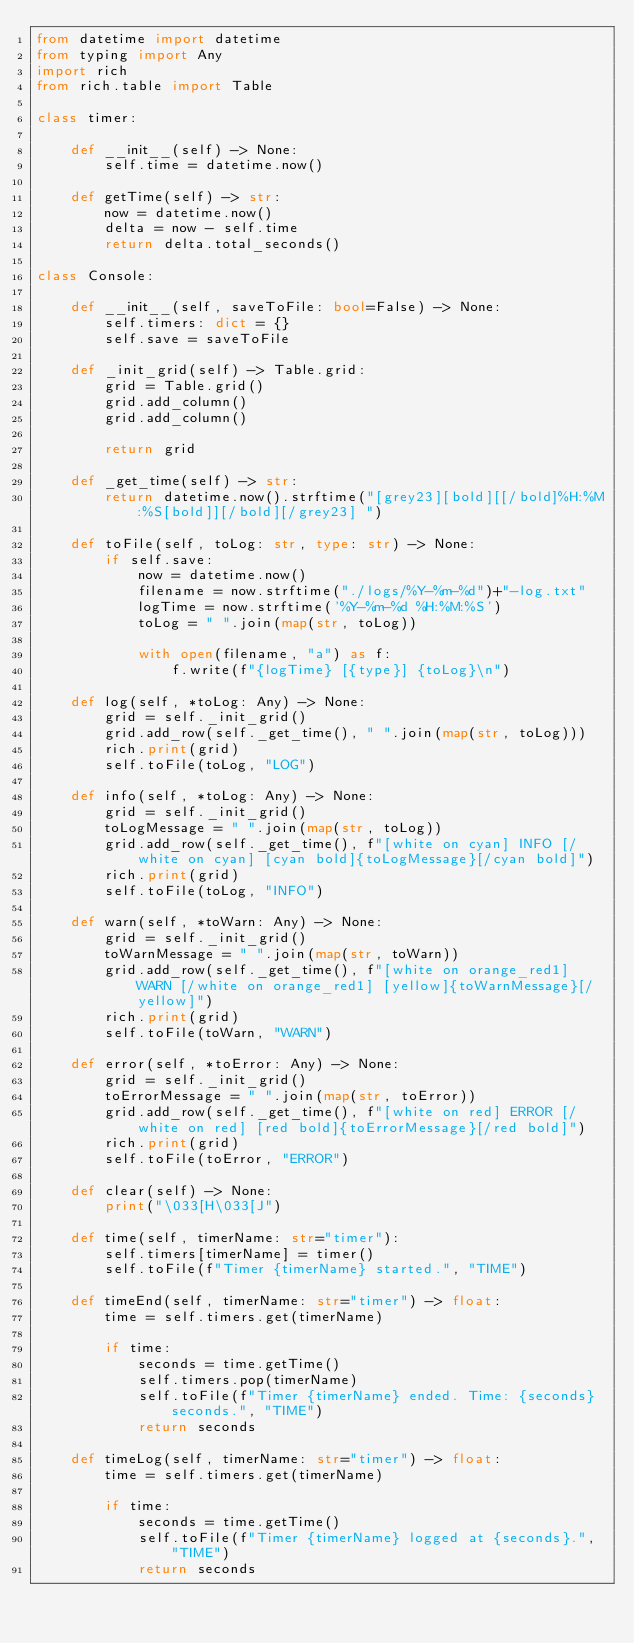Convert code to text. <code><loc_0><loc_0><loc_500><loc_500><_Python_>from datetime import datetime
from typing import Any
import rich
from rich.table import Table

class timer:

    def __init__(self) -> None:
        self.time = datetime.now()

    def getTime(self) -> str:
        now = datetime.now()
        delta = now - self.time
        return delta.total_seconds()

class Console:

    def __init__(self, saveToFile: bool=False) -> None:
        self.timers: dict = {}
        self.save = saveToFile

    def _init_grid(self) -> Table.grid:
        grid = Table.grid()
        grid.add_column()
        grid.add_column()

        return grid

    def _get_time(self) -> str:
        return datetime.now().strftime("[grey23][bold][[/bold]%H:%M:%S[bold]][/bold][/grey23] ")

    def toFile(self, toLog: str, type: str) -> None:
        if self.save:
            now = datetime.now()
            filename = now.strftime("./logs/%Y-%m-%d")+"-log.txt"
            logTime = now.strftime('%Y-%m-%d %H:%M:%S')
            toLog = " ".join(map(str, toLog))

            with open(filename, "a") as f:
                f.write(f"{logTime} [{type}] {toLog}\n")

    def log(self, *toLog: Any) -> None:
        grid = self._init_grid()
        grid.add_row(self._get_time(), " ".join(map(str, toLog)))
        rich.print(grid)
        self.toFile(toLog, "LOG")

    def info(self, *toLog: Any) -> None:
        grid = self._init_grid()
        toLogMessage = " ".join(map(str, toLog))
        grid.add_row(self._get_time(), f"[white on cyan] INFO [/white on cyan] [cyan bold]{toLogMessage}[/cyan bold]")
        rich.print(grid)
        self.toFile(toLog, "INFO")

    def warn(self, *toWarn: Any) -> None:
        grid = self._init_grid()
        toWarnMessage = " ".join(map(str, toWarn))
        grid.add_row(self._get_time(), f"[white on orange_red1] WARN [/white on orange_red1] [yellow]{toWarnMessage}[/yellow]")
        rich.print(grid)
        self.toFile(toWarn, "WARN")

    def error(self, *toError: Any) -> None:
        grid = self._init_grid()
        toErrorMessage = " ".join(map(str, toError))
        grid.add_row(self._get_time(), f"[white on red] ERROR [/white on red] [red bold]{toErrorMessage}[/red bold]")
        rich.print(grid)
        self.toFile(toError, "ERROR")

    def clear(self) -> None:
        print("\033[H\033[J")

    def time(self, timerName: str="timer"):
        self.timers[timerName] = timer()
        self.toFile(f"Timer {timerName} started.", "TIME")

    def timeEnd(self, timerName: str="timer") -> float:
        time = self.timers.get(timerName)

        if time:
            seconds = time.getTime()
            self.timers.pop(timerName)
            self.toFile(f"Timer {timerName} ended. Time: {seconds} seconds.", "TIME")
            return seconds

    def timeLog(self, timerName: str="timer") -> float:
        time = self.timers.get(timerName)

        if time:
            seconds = time.getTime()
            self.toFile(f"Timer {timerName} logged at {seconds}.", "TIME")
            return seconds</code> 